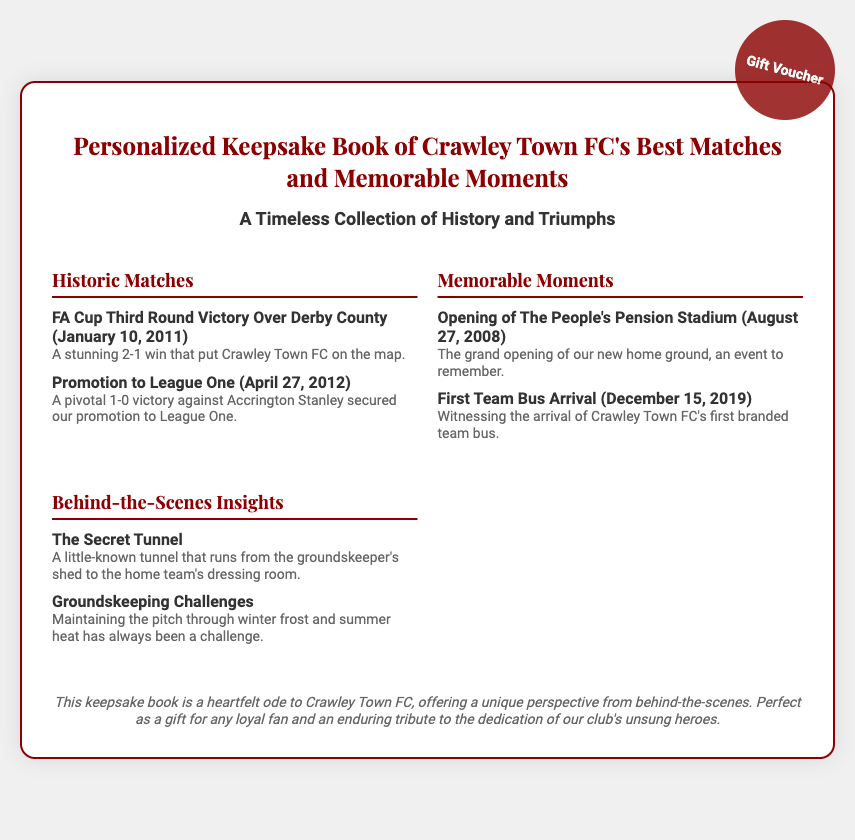what is the title of the keepsake book? The title is prominently displayed at the top of the document.
Answer: Personalized Keepsake Book of Crawley Town FC's Best Matches and Memorable Moments when did Crawley Town FC win against Derby County? The date of the historic match is provided in the description of the FA Cup victory.
Answer: January 10, 2011 what was the pivotal match for Crawley Town FC's promotion to League One? The document mentions the specific match that led to promotion.
Answer: 1-0 victory against Accrington Stanley what is the date of the grand opening of The People's Pension Stadium? The date is mentioned in the description under Memorable Moments.
Answer: August 27, 2008 what unique feature is mentioned about the groundskeeper's shed? The document specifies a particular aspect related to the shed in the Behind-the-Scenes Insights section.
Answer: A secret tunnel how has groundskeeping been a challenge for Crawley Town FC? The document highlights the difficulties faced by groundskeeping in one of the insights.
Answer: Winter frost and summer heat who is the intended recipient for the keepsake book? The last section of the document suggests who would appreciate the gift.
Answer: Any loyal fan what type of document is this? The overall theme and purpose of the document give insight into its categorization.
Answer: Gift Voucher 